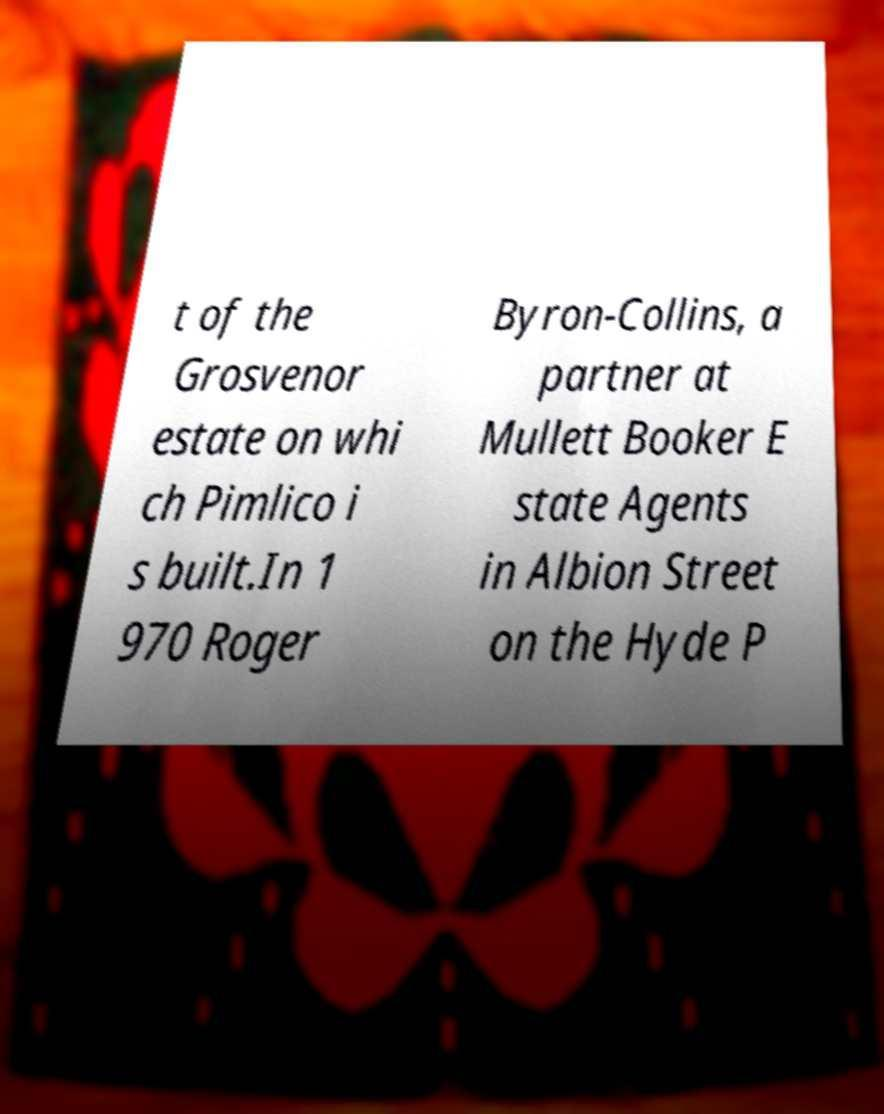For documentation purposes, I need the text within this image transcribed. Could you provide that? t of the Grosvenor estate on whi ch Pimlico i s built.In 1 970 Roger Byron-Collins, a partner at Mullett Booker E state Agents in Albion Street on the Hyde P 